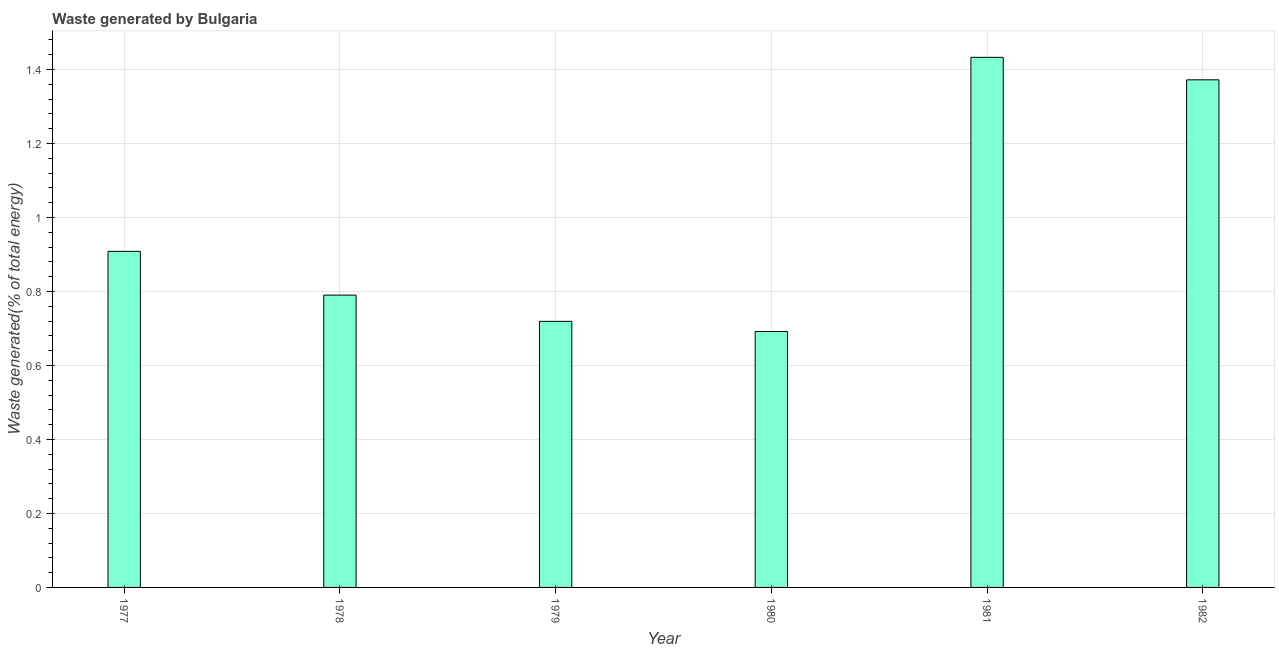Does the graph contain any zero values?
Your answer should be very brief. No. What is the title of the graph?
Provide a short and direct response. Waste generated by Bulgaria. What is the label or title of the Y-axis?
Offer a terse response. Waste generated(% of total energy). What is the amount of waste generated in 1979?
Provide a short and direct response. 0.72. Across all years, what is the maximum amount of waste generated?
Your answer should be compact. 1.43. Across all years, what is the minimum amount of waste generated?
Keep it short and to the point. 0.69. In which year was the amount of waste generated maximum?
Your answer should be compact. 1981. What is the sum of the amount of waste generated?
Make the answer very short. 5.91. What is the difference between the amount of waste generated in 1977 and 1982?
Make the answer very short. -0.46. What is the median amount of waste generated?
Keep it short and to the point. 0.85. What is the ratio of the amount of waste generated in 1977 to that in 1980?
Keep it short and to the point. 1.31. Is the amount of waste generated in 1977 less than that in 1981?
Give a very brief answer. Yes. Is the difference between the amount of waste generated in 1980 and 1981 greater than the difference between any two years?
Offer a terse response. Yes. What is the difference between the highest and the second highest amount of waste generated?
Provide a short and direct response. 0.06. Is the sum of the amount of waste generated in 1979 and 1981 greater than the maximum amount of waste generated across all years?
Provide a succinct answer. Yes. What is the difference between the highest and the lowest amount of waste generated?
Your answer should be very brief. 0.74. In how many years, is the amount of waste generated greater than the average amount of waste generated taken over all years?
Your response must be concise. 2. What is the difference between two consecutive major ticks on the Y-axis?
Ensure brevity in your answer.  0.2. Are the values on the major ticks of Y-axis written in scientific E-notation?
Offer a terse response. No. What is the Waste generated(% of total energy) of 1977?
Give a very brief answer. 0.91. What is the Waste generated(% of total energy) in 1978?
Ensure brevity in your answer.  0.79. What is the Waste generated(% of total energy) of 1979?
Provide a short and direct response. 0.72. What is the Waste generated(% of total energy) in 1980?
Ensure brevity in your answer.  0.69. What is the Waste generated(% of total energy) of 1981?
Your answer should be compact. 1.43. What is the Waste generated(% of total energy) in 1982?
Provide a succinct answer. 1.37. What is the difference between the Waste generated(% of total energy) in 1977 and 1978?
Ensure brevity in your answer.  0.12. What is the difference between the Waste generated(% of total energy) in 1977 and 1979?
Provide a short and direct response. 0.19. What is the difference between the Waste generated(% of total energy) in 1977 and 1980?
Provide a short and direct response. 0.22. What is the difference between the Waste generated(% of total energy) in 1977 and 1981?
Your answer should be compact. -0.52. What is the difference between the Waste generated(% of total energy) in 1977 and 1982?
Your response must be concise. -0.46. What is the difference between the Waste generated(% of total energy) in 1978 and 1979?
Your answer should be very brief. 0.07. What is the difference between the Waste generated(% of total energy) in 1978 and 1980?
Provide a succinct answer. 0.1. What is the difference between the Waste generated(% of total energy) in 1978 and 1981?
Offer a very short reply. -0.64. What is the difference between the Waste generated(% of total energy) in 1978 and 1982?
Provide a short and direct response. -0.58. What is the difference between the Waste generated(% of total energy) in 1979 and 1980?
Provide a succinct answer. 0.03. What is the difference between the Waste generated(% of total energy) in 1979 and 1981?
Make the answer very short. -0.71. What is the difference between the Waste generated(% of total energy) in 1979 and 1982?
Your answer should be very brief. -0.65. What is the difference between the Waste generated(% of total energy) in 1980 and 1981?
Your answer should be compact. -0.74. What is the difference between the Waste generated(% of total energy) in 1980 and 1982?
Offer a very short reply. -0.68. What is the difference between the Waste generated(% of total energy) in 1981 and 1982?
Provide a short and direct response. 0.06. What is the ratio of the Waste generated(% of total energy) in 1977 to that in 1978?
Your response must be concise. 1.15. What is the ratio of the Waste generated(% of total energy) in 1977 to that in 1979?
Provide a short and direct response. 1.26. What is the ratio of the Waste generated(% of total energy) in 1977 to that in 1980?
Make the answer very short. 1.31. What is the ratio of the Waste generated(% of total energy) in 1977 to that in 1981?
Provide a succinct answer. 0.63. What is the ratio of the Waste generated(% of total energy) in 1977 to that in 1982?
Provide a succinct answer. 0.66. What is the ratio of the Waste generated(% of total energy) in 1978 to that in 1979?
Your answer should be very brief. 1.1. What is the ratio of the Waste generated(% of total energy) in 1978 to that in 1980?
Your answer should be compact. 1.14. What is the ratio of the Waste generated(% of total energy) in 1978 to that in 1981?
Your answer should be very brief. 0.55. What is the ratio of the Waste generated(% of total energy) in 1978 to that in 1982?
Make the answer very short. 0.58. What is the ratio of the Waste generated(% of total energy) in 1979 to that in 1980?
Offer a terse response. 1.04. What is the ratio of the Waste generated(% of total energy) in 1979 to that in 1981?
Offer a very short reply. 0.5. What is the ratio of the Waste generated(% of total energy) in 1979 to that in 1982?
Your response must be concise. 0.52. What is the ratio of the Waste generated(% of total energy) in 1980 to that in 1981?
Make the answer very short. 0.48. What is the ratio of the Waste generated(% of total energy) in 1980 to that in 1982?
Your response must be concise. 0.5. What is the ratio of the Waste generated(% of total energy) in 1981 to that in 1982?
Offer a very short reply. 1.04. 